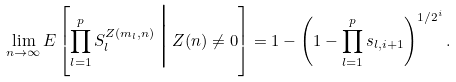<formula> <loc_0><loc_0><loc_500><loc_500>\lim _ { n \rightarrow \infty } E \left [ \prod _ { l = 1 } ^ { p } S _ { l } ^ { Z ( m _ { l } , n ) } \, \Big | \, Z ( n ) \neq 0 \right ] = 1 - \left ( 1 - \prod _ { l = 1 } ^ { p } s _ { l , i + 1 } \right ) ^ { 1 / 2 ^ { i } } .</formula> 